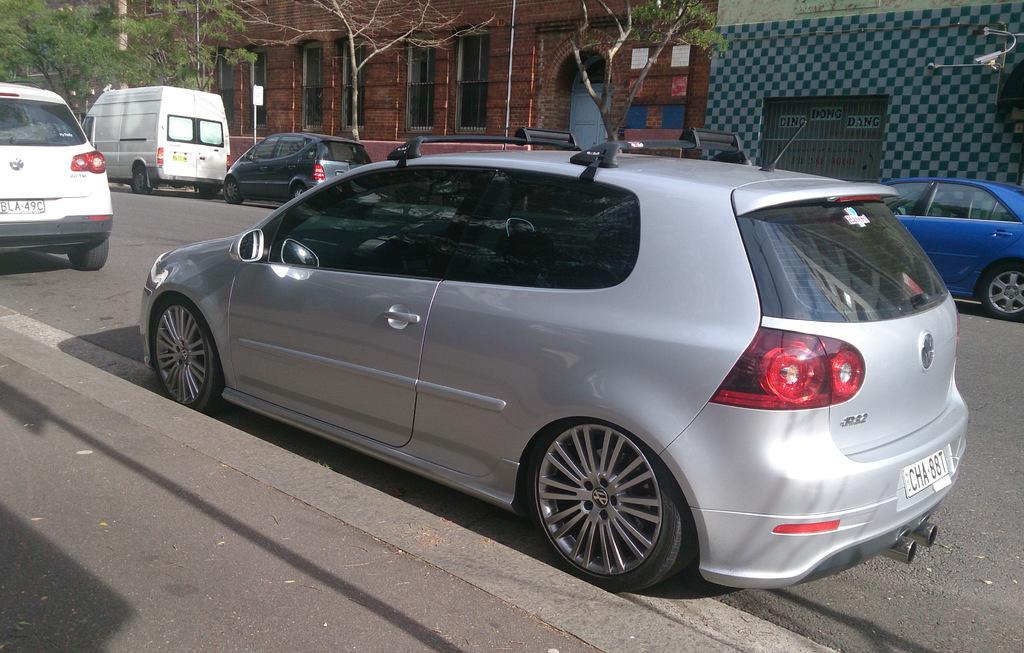In one or two sentences, can you explain what this image depicts? In this image we can see some vehicles on the road, there are few buildings, trees, also we can see some text on the wall. 